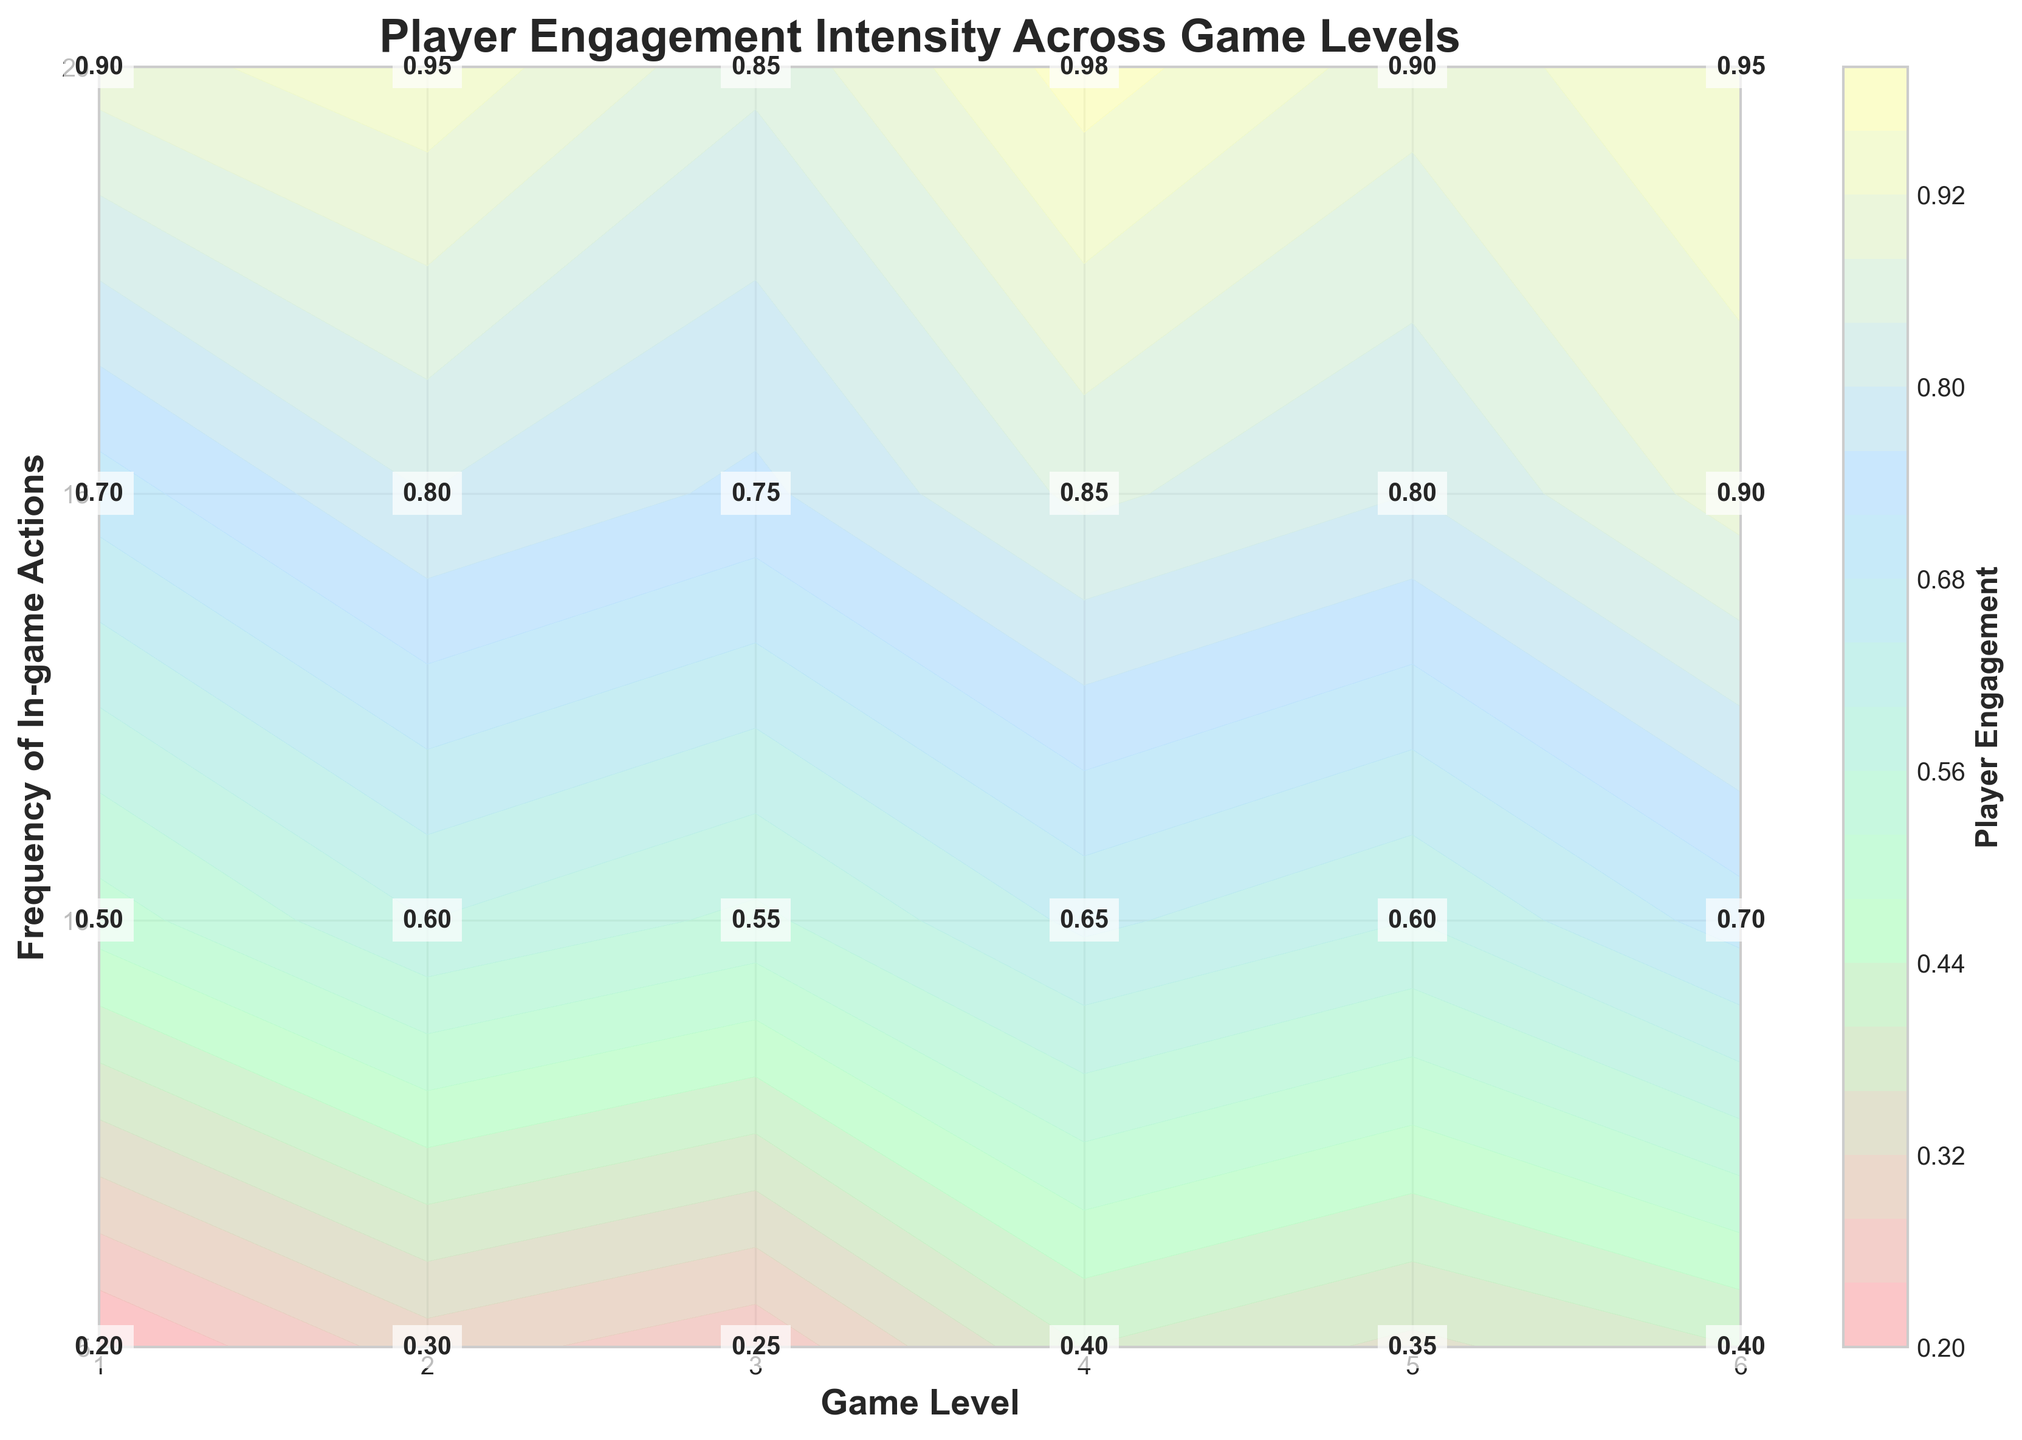What is the title of the plot? The title of the plot is displayed prominently at the top of the figure. By looking at the title, we can determine it easily.
Answer: Player Engagement Intensity Across Game Levels How is the x-axis labeled? The label for the x-axis is usually placed along or near the x-axis itself. This label indicates what the x-axis represents.
Answer: Game Level What color represents the highest engagement level? The color representing the highest engagement level can be identified by looking at the colorbar gradient and matching it with the highest value indicated.
Answer: Darker color (close to #FFFFBA) At which game level and frequency of in-game actions do we see the highest player engagement? By examining the contour plot and finding the highest value (0.98) from the contours and/or text annotations, we can see which combination of game level and action frequency it corresponds to.
Answer: Level 4, 20 actions What is the player engagement at level 3 with 15 in-game actions? Find the coordinates corresponding to level 3 and 15 in-game actions in the plot. The text annotations or contours will show the engagement value.
Answer: 0.75 Compare the player engagement between level 6 and level 1 when the frequency of in-game actions is 10. Which level shows higher engagement? Look at the values for level 6 and level 1 with 10 in-game actions. Compare '0.7' at level 6 and '0.5' at level 1.
Answer: Level 6 (0.7) What is the average player engagement across all game levels when the frequency of in-game actions is 20? Identify values for when actions are 20: (0.9, 0.95, 0.85, 0.98, 0.9, 0.95). Calculate the average: (0.9 + 0.95 + 0.85 + 0.98 + 0.9 + 0.95) / 6.
Answer: 0.92 Which level has the lowest player engagement at the lowest frequency of in-game actions? Look at the engagement values at 5 in-game actions for each level. Identify the smallest value. Levels: (0.2, 0.3, 0.25, 0.4, 0.35, 0.4).
Answer: Level 1 (0.2) How does the player engagement change from level 2 to level 3 at 10 in-game actions? Compare the values at 10 actions between level 2 and level 3. Level 2: 0.6, Level 3: 0.55.
Answer: Decreases (from 0.6 to 0.55) What is the difference in player engagement between the maximum frequency and the minimum frequency of in-game actions at level 5? Identify values at level 5 for 20 actions and 5 actions (0.9 and 0.35). Calculate the difference: 0.9 - 0.35.
Answer: 0.55 